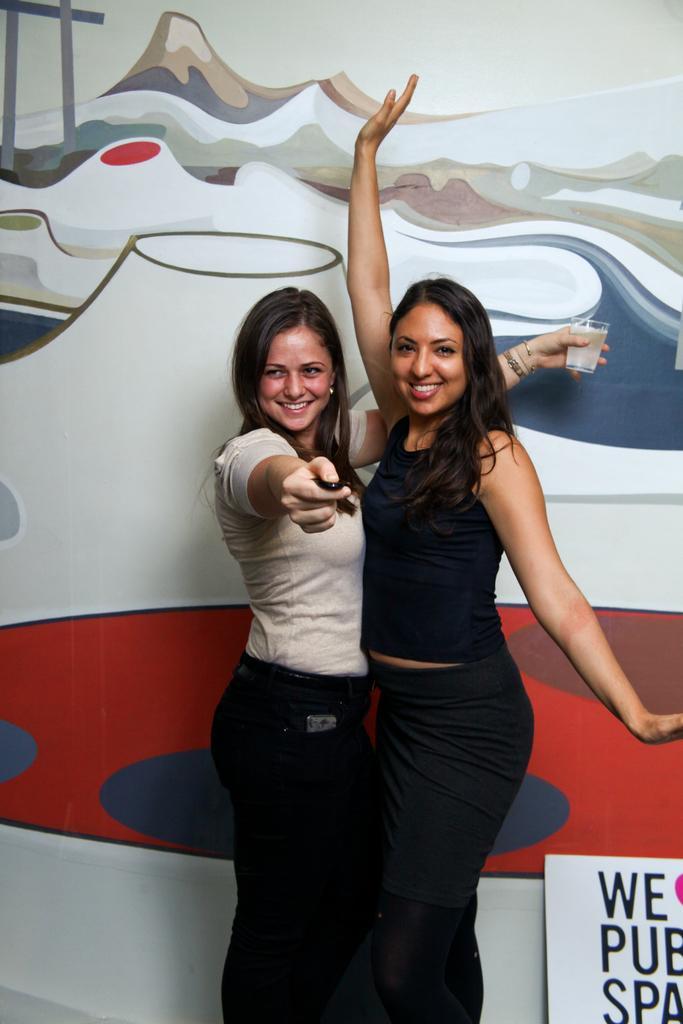How would you summarize this image in a sentence or two? Middle of the image we can see two women are standing and smiling. One woman is holding a glass. Background there is a board and painted wall. 